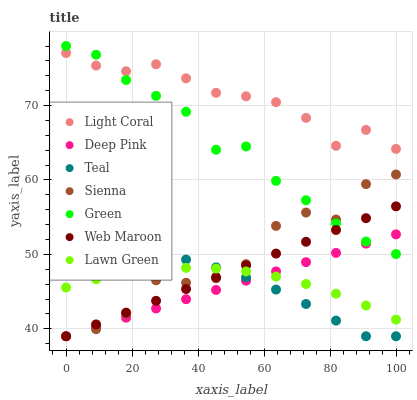Does Deep Pink have the minimum area under the curve?
Answer yes or no. Yes. Does Light Coral have the maximum area under the curve?
Answer yes or no. Yes. Does Lawn Green have the minimum area under the curve?
Answer yes or no. No. Does Lawn Green have the maximum area under the curve?
Answer yes or no. No. Is Deep Pink the smoothest?
Answer yes or no. Yes. Is Sienna the roughest?
Answer yes or no. Yes. Is Lawn Green the smoothest?
Answer yes or no. No. Is Lawn Green the roughest?
Answer yes or no. No. Does Sienna have the lowest value?
Answer yes or no. Yes. Does Lawn Green have the lowest value?
Answer yes or no. No. Does Green have the highest value?
Answer yes or no. Yes. Does Deep Pink have the highest value?
Answer yes or no. No. Is Teal less than Light Coral?
Answer yes or no. Yes. Is Light Coral greater than Deep Pink?
Answer yes or no. Yes. Does Sienna intersect Web Maroon?
Answer yes or no. Yes. Is Sienna less than Web Maroon?
Answer yes or no. No. Is Sienna greater than Web Maroon?
Answer yes or no. No. Does Teal intersect Light Coral?
Answer yes or no. No. 